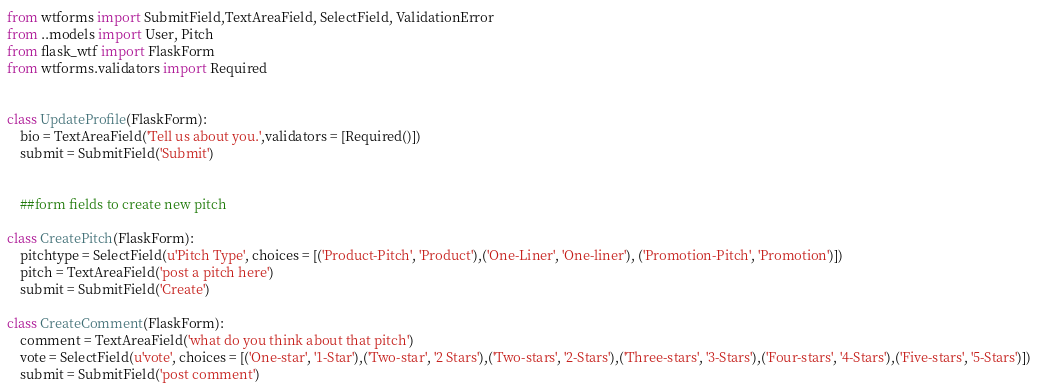Convert code to text. <code><loc_0><loc_0><loc_500><loc_500><_Python_>from wtforms import SubmitField,TextAreaField, SelectField, ValidationError
from ..models import User, Pitch
from flask_wtf import FlaskForm
from wtforms.validators import Required


class UpdateProfile(FlaskForm):
    bio = TextAreaField('Tell us about you.',validators = [Required()])
    submit = SubmitField('Submit')


    ##form fields to create new pitch

class CreatePitch(FlaskForm):
    pitchtype = SelectField(u'Pitch Type', choices = [('Product-Pitch', 'Product'),('One-Liner', 'One-liner'), ('Promotion-Pitch', 'Promotion')])
    pitch = TextAreaField('post a pitch here')
    submit = SubmitField('Create')

class CreateComment(FlaskForm):
    comment = TextAreaField('what do you think about that pitch')
    vote = SelectField(u'vote', choices = [('One-star', '1-Star'),('Two-star', '2 Stars'),('Two-stars', '2-Stars'),('Three-stars', '3-Stars'),('Four-stars', '4-Stars'),('Five-stars', '5-Stars')])
    submit = SubmitField('post comment') </code> 